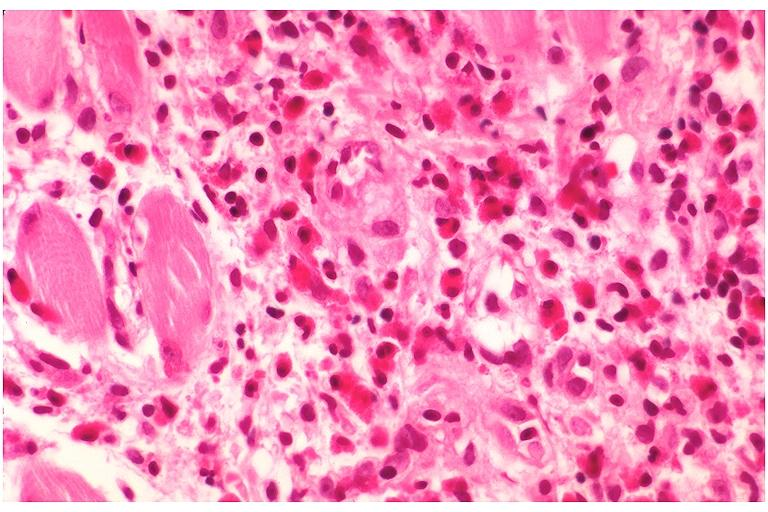where is this?
Answer the question using a single word or phrase. Oral 